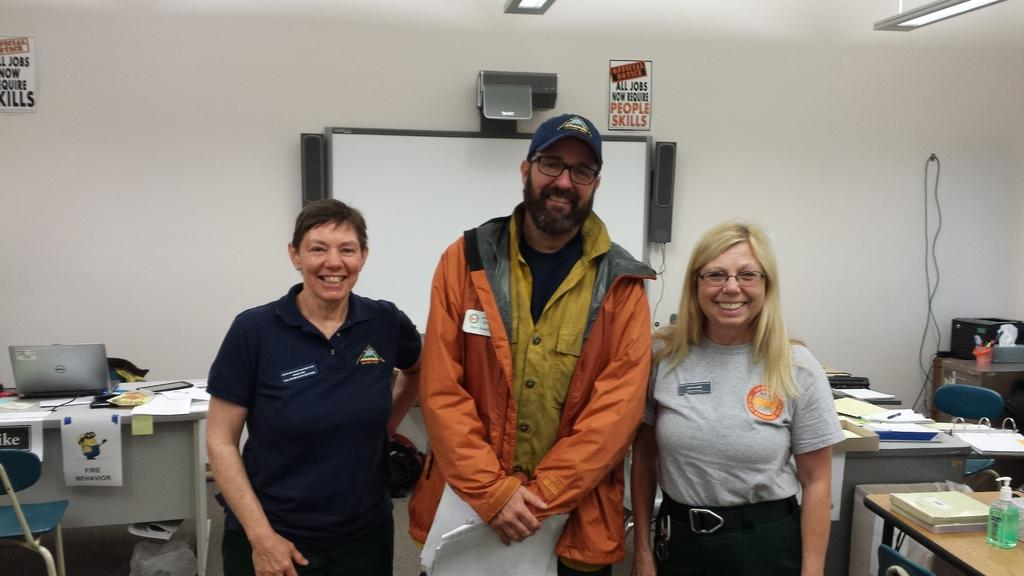How many people are present in the image? There are three people standing in the image. What objects can be seen on a table in the background? There is a laptop and papers on a table in the background. What electronic devices are visible in the background? There is a monitor and speakers in the background. What type of lighting is present in the background? There are lights on the ceiling in the background. What type of needle is being used by one of the people in the image? There is no needle present in the image. What type of badge is being worn by one of the people in the image? There is no badge visible on any of the people in the image. 